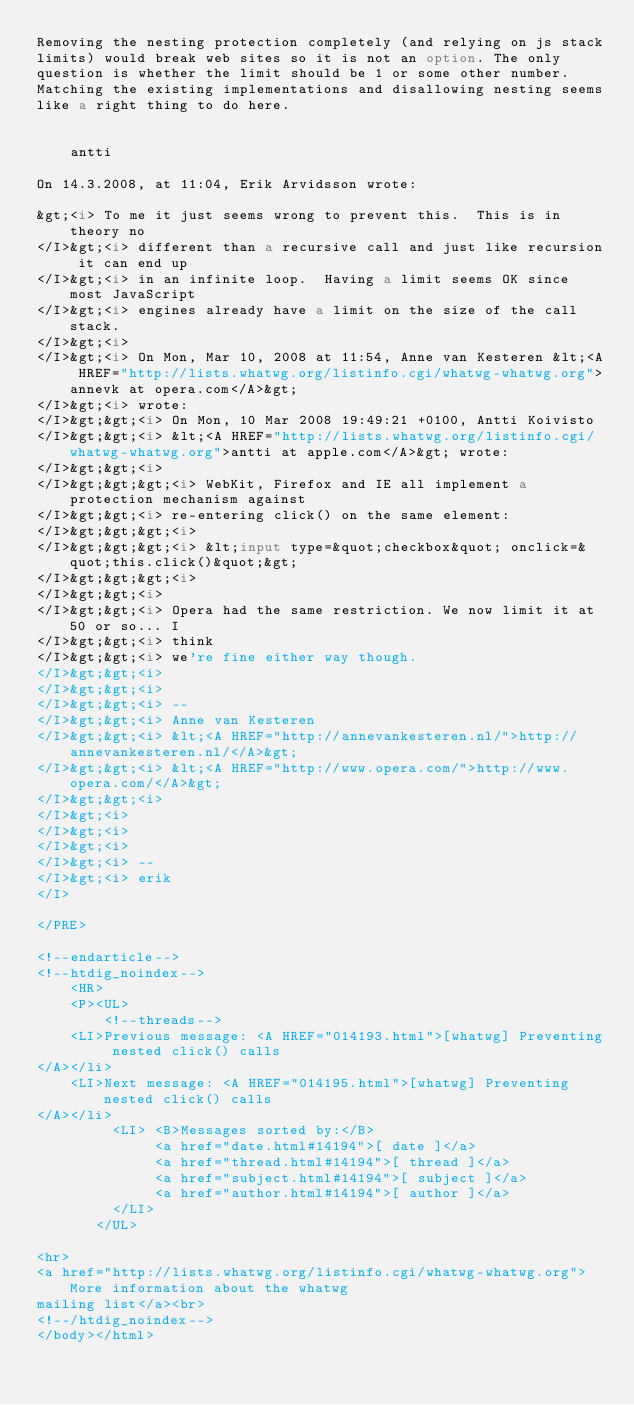<code> <loc_0><loc_0><loc_500><loc_500><_HTML_>Removing the nesting protection completely (and relying on js stack  
limits) would break web sites so it is not an option. The only  
question is whether the limit should be 1 or some other number.  
Matching the existing implementations and disallowing nesting seems  
like a right thing to do here.


    antti

On 14.3.2008, at 11:04, Erik Arvidsson wrote:

&gt;<i> To me it just seems wrong to prevent this.  This is in theory no
</I>&gt;<i> different than a recursive call and just like recursion it can end up
</I>&gt;<i> in an infinite loop.  Having a limit seems OK since most JavaScript
</I>&gt;<i> engines already have a limit on the size of the call stack.
</I>&gt;<i>
</I>&gt;<i> On Mon, Mar 10, 2008 at 11:54, Anne van Kesteren &lt;<A HREF="http://lists.whatwg.org/listinfo.cgi/whatwg-whatwg.org">annevk at opera.com</A>&gt;  
</I>&gt;<i> wrote:
</I>&gt;&gt;<i> On Mon, 10 Mar 2008 19:49:21 +0100, Antti Koivisto  
</I>&gt;&gt;<i> &lt;<A HREF="http://lists.whatwg.org/listinfo.cgi/whatwg-whatwg.org">antti at apple.com</A>&gt; wrote:
</I>&gt;&gt;<i>
</I>&gt;&gt;&gt;<i> WebKit, Firefox and IE all implement a protection mechanism against
</I>&gt;&gt;<i> re-entering click() on the same element:
</I>&gt;&gt;&gt;<i>
</I>&gt;&gt;&gt;<i> &lt;input type=&quot;checkbox&quot; onclick=&quot;this.click()&quot;&gt;
</I>&gt;&gt;&gt;<i>
</I>&gt;&gt;<i>
</I>&gt;&gt;<i> Opera had the same restriction. We now limit it at 50 or so... I  
</I>&gt;&gt;<i> think
</I>&gt;&gt;<i> we're fine either way though.
</I>&gt;&gt;<i>
</I>&gt;&gt;<i>
</I>&gt;&gt;<i> --
</I>&gt;&gt;<i> Anne van Kesteren
</I>&gt;&gt;<i> &lt;<A HREF="http://annevankesteren.nl/">http://annevankesteren.nl/</A>&gt;
</I>&gt;&gt;<i> &lt;<A HREF="http://www.opera.com/">http://www.opera.com/</A>&gt;
</I>&gt;&gt;<i>
</I>&gt;<i>
</I>&gt;<i>
</I>&gt;<i>
</I>&gt;<i> -- 
</I>&gt;<i> erik
</I>

</PRE>

<!--endarticle-->
<!--htdig_noindex-->
    <HR>
    <P><UL>
        <!--threads-->
	<LI>Previous message: <A HREF="014193.html">[whatwg] Preventing nested click() calls
</A></li>
	<LI>Next message: <A HREF="014195.html">[whatwg] Preventing nested click() calls
</A></li>
         <LI> <B>Messages sorted by:</B> 
              <a href="date.html#14194">[ date ]</a>
              <a href="thread.html#14194">[ thread ]</a>
              <a href="subject.html#14194">[ subject ]</a>
              <a href="author.html#14194">[ author ]</a>
         </LI>
       </UL>

<hr>
<a href="http://lists.whatwg.org/listinfo.cgi/whatwg-whatwg.org">More information about the whatwg
mailing list</a><br>
<!--/htdig_noindex-->
</body></html>
</code> 